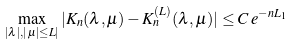Convert formula to latex. <formula><loc_0><loc_0><loc_500><loc_500>\max _ { | \lambda | , | \mu | \leq L | } | K _ { n } ( \lambda , \mu ) - K _ { n } ^ { ( L ) } ( \lambda , \mu ) | \leq C \, e ^ { - n L _ { 1 } }</formula> 